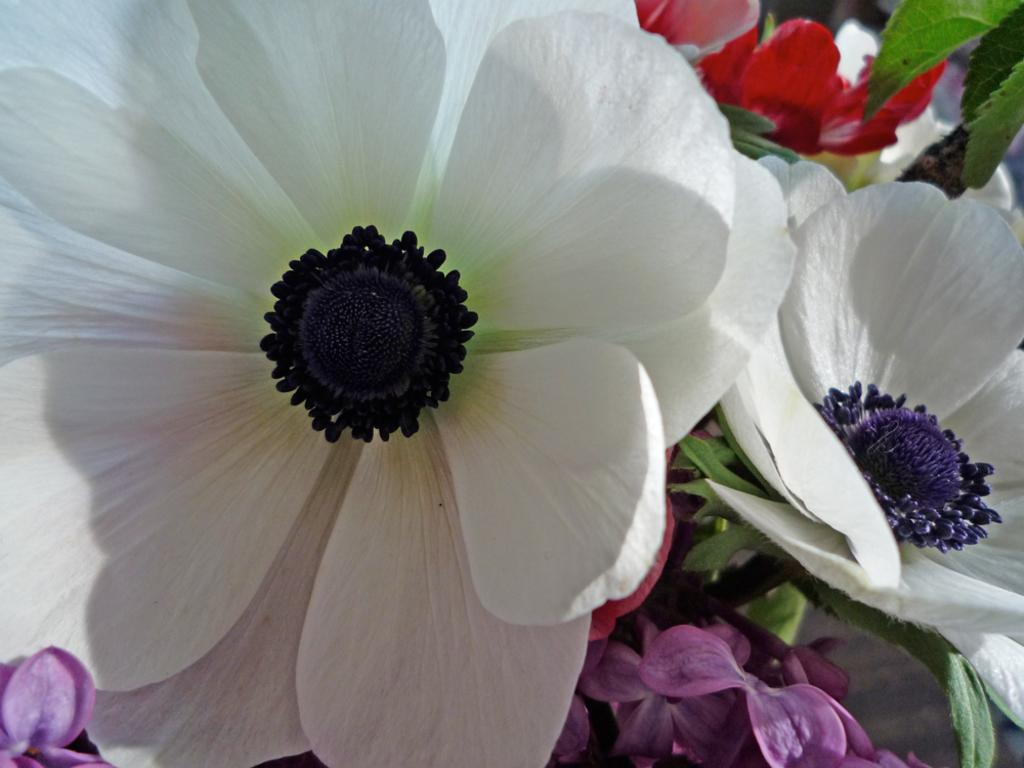What type of plants can be seen in the image? There are flowers in the image. What colors are present on the flowers? The flowers have white, violet, and red colors. What color is the middle part of the flowers? The middle part of the flowers is in blue color. Are there any other parts of the flowers visible in the image? Yes, there are leaves in the image. What type of boat is depicted in the image? There is no boat present in the image; it features flowers with various colors and leaves. 